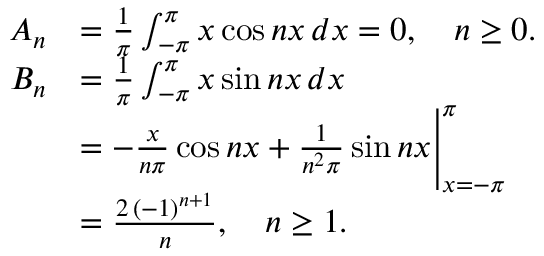<formula> <loc_0><loc_0><loc_500><loc_500>{ \begin{array} { r l } { A _ { n } } & { = { \frac { 1 } { \pi } } \int _ { - \pi } ^ { \pi } x \cos { n x } \, d x = 0 , \quad n \geq 0 . } \\ { B _ { n } } & { = { \frac { 1 } { \pi } } \int _ { - \pi } ^ { \pi } x \sin { n x } \, d x } \\ & { = - { \frac { x } { n \pi } } \cos { n x } + { \frac { 1 } { n ^ { 2 } \pi } } \sin { n x } { \Big | } _ { x = - \pi } ^ { \pi } } \\ & { = { \frac { 2 \, ( - 1 ) ^ { n + 1 } } { n } } , \quad n \geq 1 . } \end{array} }</formula> 